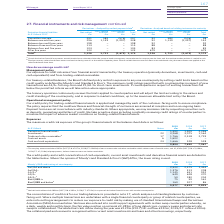According to Bt Group Plc's financial document, What amount of non-current trade and other receivables was excluded from the carrying amount in 2019? According to the financial document, £445m. The relevant text states: "a The carrying amount excludes £445m (2017/18: £317m, 2016/17: £360m) of non-current trade and other receivables which relate to non-fina..." Also, What was the Derivative financial assets in 2019, 2018 and 2017? The document contains multiple relevant values: 1,592, 1,509, 2,246 (in millions). From the document: "Derivative financial assets 1,592 1,509 2,246 Investments 23 3,268 3,075 1,564 Trade and other receivables a 17 1,766 2,518 2,729 Contract assets Deri..." Also, What is theCash and cash equivalents for 2017, 2018 and 2019 respectively? The document contains multiple relevant values: 528, 528, 1,666 (in millions). From the document: "ts 6 1,602 – – Cash and cash equivalents 24 1,666 528 528 t assets 6 1,602 – – Cash and cash equivalents 24 1,666 528 528..." Also, can you calculate: What is the change in the Derivative financial assets from 2018 to 2019? Based on the calculation: 1,592 - 1,509, the result is 83 (in millions). This is based on the information: "Derivative financial assets 1,592 1,509 2,246 Investments 23 3,268 3,075 1,564 Trade and other receivables a 17 1,766 2,518 2,729 Con Derivative financial assets 1,592 1,509 2,246 Investments 23 3,268..." The key data points involved are: 1,509, 1,592. Also, can you calculate: What is the average investments for 2017 to 2019? To answer this question, I need to perform calculations using the financial data. The calculation is: (3,268 + 3,075 + 1,564) / 3, which equals 2635.67 (in millions). This is based on the information: "ial assets 1,592 1,509 2,246 Investments 23 3,268 3,075 1,564 Trade and other receivables a 17 1,766 2,518 2,729 Contract assets 6 1,602 – – Cash and cash financial assets 1,592 1,509 2,246 Investment..." The key data points involved are: 1,564, 3,075, 3,268. Additionally, In which year(s) was trade and other receivables less than 2,000 million? According to the financial document, 2019. The relevant text states: "At 31 March Notes 2019 £m 2018 £m 2017 £m..." 